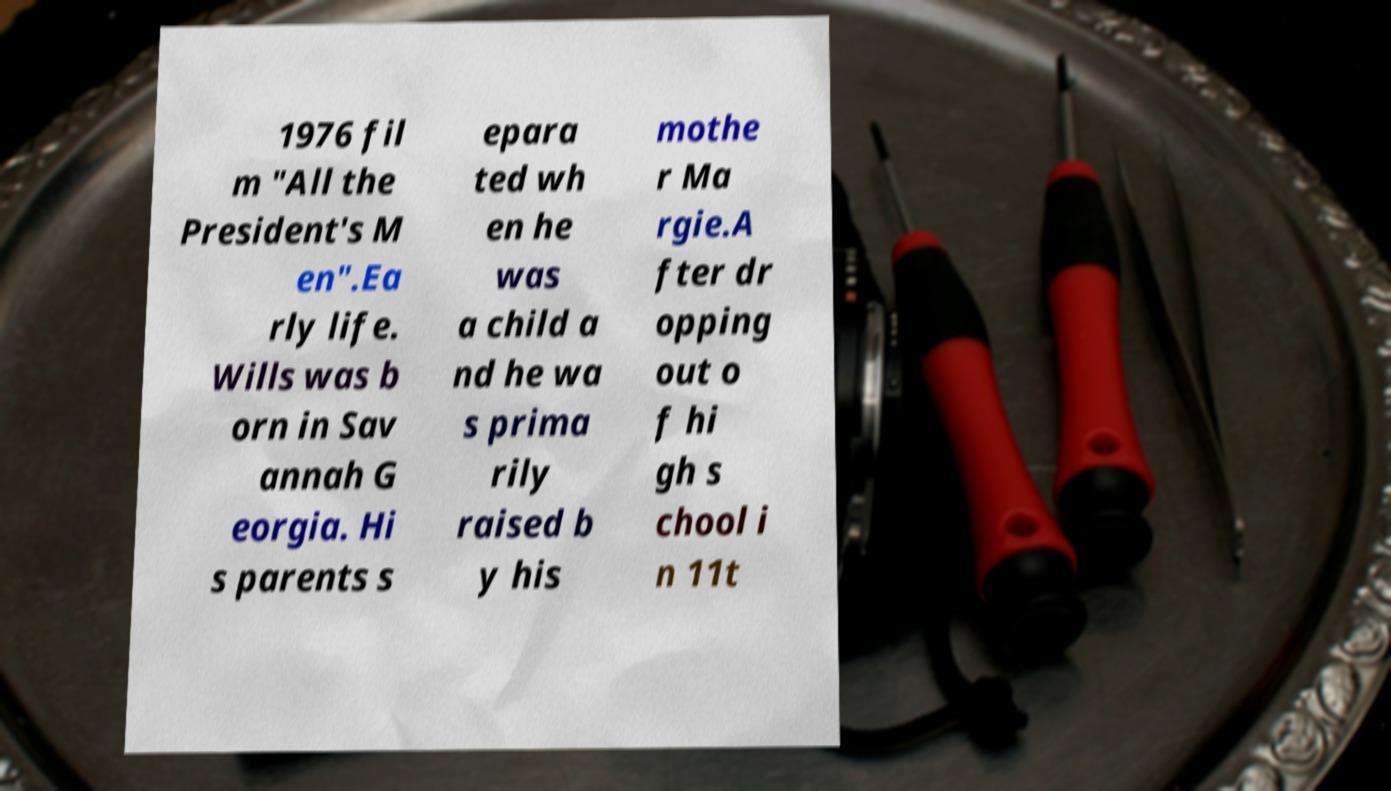For documentation purposes, I need the text within this image transcribed. Could you provide that? 1976 fil m "All the President's M en".Ea rly life. Wills was b orn in Sav annah G eorgia. Hi s parents s epara ted wh en he was a child a nd he wa s prima rily raised b y his mothe r Ma rgie.A fter dr opping out o f hi gh s chool i n 11t 